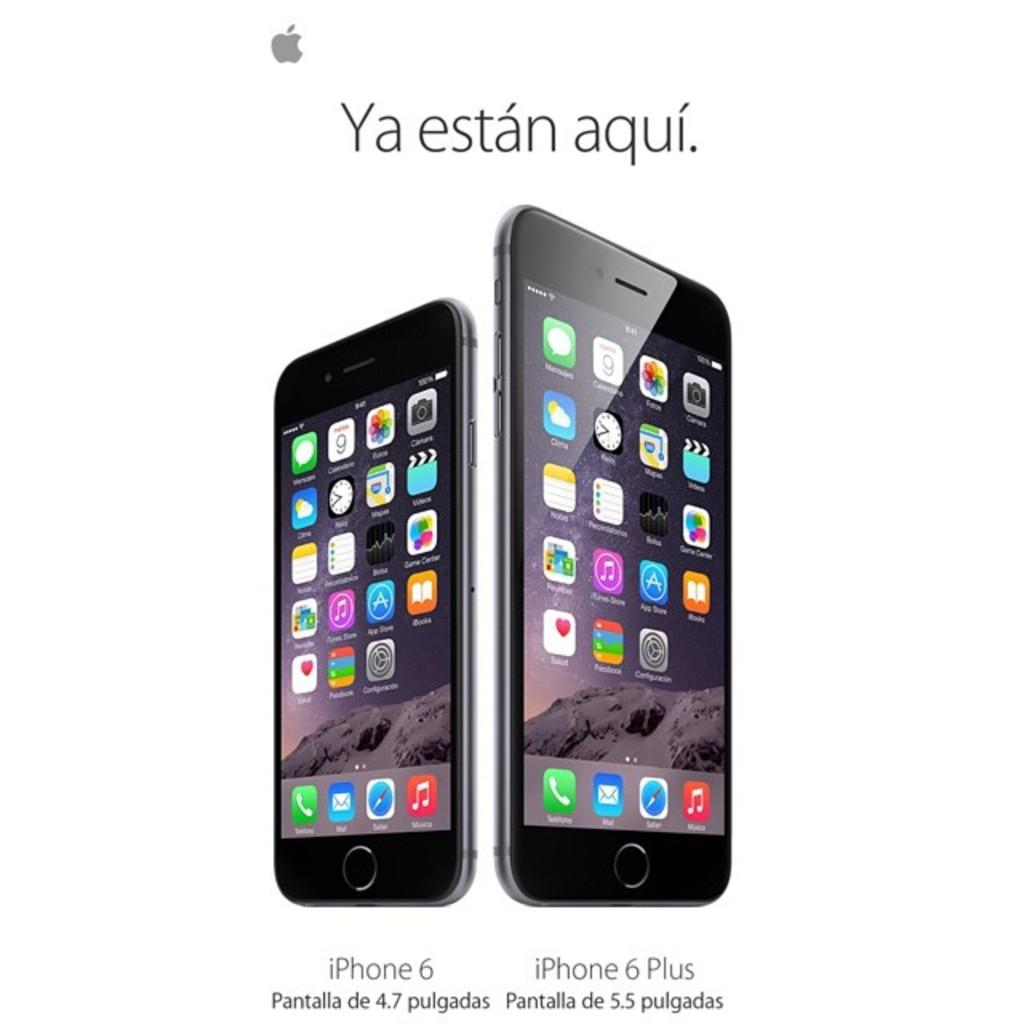<image>
Relay a brief, clear account of the picture shown. Two iphones side by side showing a comparison of size between them. 